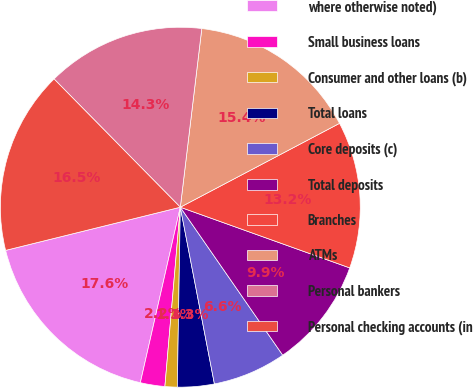<chart> <loc_0><loc_0><loc_500><loc_500><pie_chart><fcel>where otherwise noted)<fcel>Small business loans<fcel>Consumer and other loans (b)<fcel>Total loans<fcel>Core deposits (c)<fcel>Total deposits<fcel>Branches<fcel>ATMs<fcel>Personal bankers<fcel>Personal checking accounts (in<nl><fcel>17.58%<fcel>2.2%<fcel>1.1%<fcel>3.3%<fcel>6.6%<fcel>9.89%<fcel>13.19%<fcel>15.38%<fcel>14.28%<fcel>16.48%<nl></chart> 